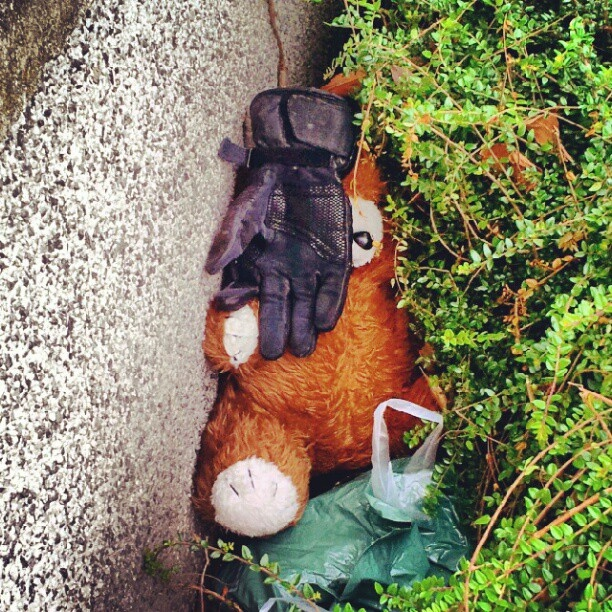Describe the objects in this image and their specific colors. I can see a teddy bear in black, brown, lightgray, and maroon tones in this image. 